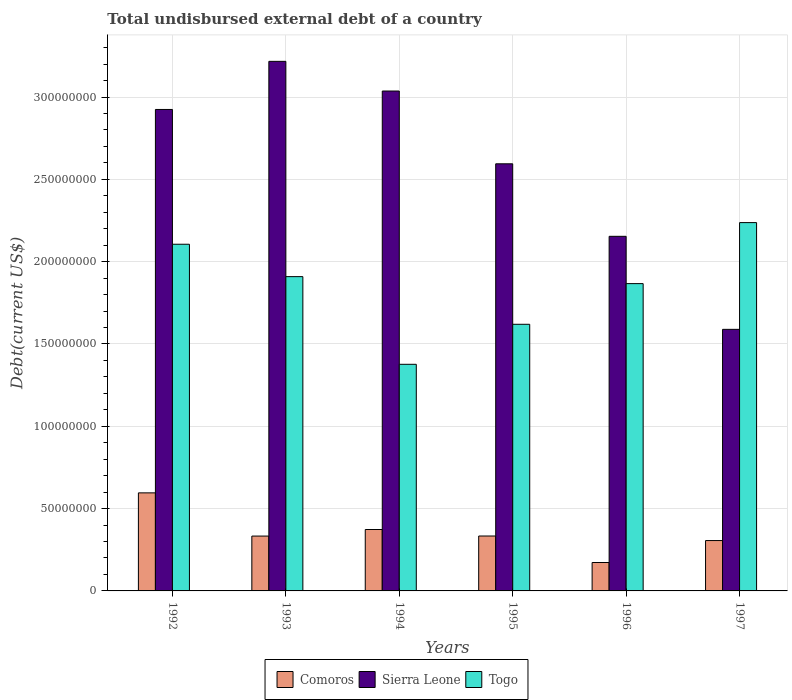How many different coloured bars are there?
Your response must be concise. 3. How many groups of bars are there?
Make the answer very short. 6. Are the number of bars per tick equal to the number of legend labels?
Provide a short and direct response. Yes. Are the number of bars on each tick of the X-axis equal?
Offer a very short reply. Yes. What is the label of the 5th group of bars from the left?
Your response must be concise. 1996. What is the total undisbursed external debt in Sierra Leone in 1993?
Ensure brevity in your answer.  3.22e+08. Across all years, what is the maximum total undisbursed external debt in Comoros?
Your answer should be very brief. 5.96e+07. Across all years, what is the minimum total undisbursed external debt in Comoros?
Offer a very short reply. 1.73e+07. What is the total total undisbursed external debt in Togo in the graph?
Give a very brief answer. 1.11e+09. What is the difference between the total undisbursed external debt in Comoros in 1994 and that in 1996?
Provide a succinct answer. 2.00e+07. What is the difference between the total undisbursed external debt in Sierra Leone in 1994 and the total undisbursed external debt in Comoros in 1995?
Offer a terse response. 2.70e+08. What is the average total undisbursed external debt in Comoros per year?
Keep it short and to the point. 3.52e+07. In the year 1997, what is the difference between the total undisbursed external debt in Sierra Leone and total undisbursed external debt in Comoros?
Offer a terse response. 1.28e+08. What is the ratio of the total undisbursed external debt in Comoros in 1993 to that in 1995?
Provide a short and direct response. 1. What is the difference between the highest and the second highest total undisbursed external debt in Sierra Leone?
Your response must be concise. 1.80e+07. What is the difference between the highest and the lowest total undisbursed external debt in Sierra Leone?
Provide a succinct answer. 1.63e+08. In how many years, is the total undisbursed external debt in Togo greater than the average total undisbursed external debt in Togo taken over all years?
Offer a very short reply. 4. What does the 3rd bar from the left in 1994 represents?
Keep it short and to the point. Togo. What does the 3rd bar from the right in 1997 represents?
Give a very brief answer. Comoros. What is the difference between two consecutive major ticks on the Y-axis?
Ensure brevity in your answer.  5.00e+07. Are the values on the major ticks of Y-axis written in scientific E-notation?
Offer a terse response. No. How are the legend labels stacked?
Provide a short and direct response. Horizontal. What is the title of the graph?
Keep it short and to the point. Total undisbursed external debt of a country. Does "Chad" appear as one of the legend labels in the graph?
Your answer should be compact. No. What is the label or title of the Y-axis?
Provide a short and direct response. Debt(current US$). What is the Debt(current US$) of Comoros in 1992?
Make the answer very short. 5.96e+07. What is the Debt(current US$) in Sierra Leone in 1992?
Your answer should be very brief. 2.92e+08. What is the Debt(current US$) of Togo in 1992?
Your answer should be very brief. 2.11e+08. What is the Debt(current US$) in Comoros in 1993?
Keep it short and to the point. 3.33e+07. What is the Debt(current US$) of Sierra Leone in 1993?
Your answer should be compact. 3.22e+08. What is the Debt(current US$) of Togo in 1993?
Provide a succinct answer. 1.91e+08. What is the Debt(current US$) in Comoros in 1994?
Keep it short and to the point. 3.73e+07. What is the Debt(current US$) in Sierra Leone in 1994?
Offer a very short reply. 3.04e+08. What is the Debt(current US$) in Togo in 1994?
Provide a short and direct response. 1.38e+08. What is the Debt(current US$) of Comoros in 1995?
Give a very brief answer. 3.34e+07. What is the Debt(current US$) of Sierra Leone in 1995?
Provide a succinct answer. 2.59e+08. What is the Debt(current US$) of Togo in 1995?
Keep it short and to the point. 1.62e+08. What is the Debt(current US$) of Comoros in 1996?
Provide a succinct answer. 1.73e+07. What is the Debt(current US$) of Sierra Leone in 1996?
Keep it short and to the point. 2.15e+08. What is the Debt(current US$) of Togo in 1996?
Your answer should be compact. 1.87e+08. What is the Debt(current US$) of Comoros in 1997?
Your answer should be very brief. 3.06e+07. What is the Debt(current US$) of Sierra Leone in 1997?
Offer a very short reply. 1.59e+08. What is the Debt(current US$) of Togo in 1997?
Your response must be concise. 2.24e+08. Across all years, what is the maximum Debt(current US$) in Comoros?
Give a very brief answer. 5.96e+07. Across all years, what is the maximum Debt(current US$) in Sierra Leone?
Ensure brevity in your answer.  3.22e+08. Across all years, what is the maximum Debt(current US$) of Togo?
Keep it short and to the point. 2.24e+08. Across all years, what is the minimum Debt(current US$) of Comoros?
Offer a very short reply. 1.73e+07. Across all years, what is the minimum Debt(current US$) of Sierra Leone?
Provide a short and direct response. 1.59e+08. Across all years, what is the minimum Debt(current US$) in Togo?
Give a very brief answer. 1.38e+08. What is the total Debt(current US$) in Comoros in the graph?
Keep it short and to the point. 2.11e+08. What is the total Debt(current US$) in Sierra Leone in the graph?
Your answer should be very brief. 1.55e+09. What is the total Debt(current US$) in Togo in the graph?
Provide a short and direct response. 1.11e+09. What is the difference between the Debt(current US$) of Comoros in 1992 and that in 1993?
Give a very brief answer. 2.62e+07. What is the difference between the Debt(current US$) of Sierra Leone in 1992 and that in 1993?
Keep it short and to the point. -2.92e+07. What is the difference between the Debt(current US$) in Togo in 1992 and that in 1993?
Offer a very short reply. 1.97e+07. What is the difference between the Debt(current US$) of Comoros in 1992 and that in 1994?
Give a very brief answer. 2.23e+07. What is the difference between the Debt(current US$) in Sierra Leone in 1992 and that in 1994?
Your answer should be compact. -1.12e+07. What is the difference between the Debt(current US$) in Togo in 1992 and that in 1994?
Give a very brief answer. 7.29e+07. What is the difference between the Debt(current US$) of Comoros in 1992 and that in 1995?
Offer a very short reply. 2.62e+07. What is the difference between the Debt(current US$) in Sierra Leone in 1992 and that in 1995?
Offer a very short reply. 3.30e+07. What is the difference between the Debt(current US$) in Togo in 1992 and that in 1995?
Your answer should be very brief. 4.86e+07. What is the difference between the Debt(current US$) of Comoros in 1992 and that in 1996?
Make the answer very short. 4.23e+07. What is the difference between the Debt(current US$) of Sierra Leone in 1992 and that in 1996?
Your response must be concise. 7.71e+07. What is the difference between the Debt(current US$) of Togo in 1992 and that in 1996?
Give a very brief answer. 2.39e+07. What is the difference between the Debt(current US$) of Comoros in 1992 and that in 1997?
Make the answer very short. 2.90e+07. What is the difference between the Debt(current US$) in Sierra Leone in 1992 and that in 1997?
Your response must be concise. 1.34e+08. What is the difference between the Debt(current US$) in Togo in 1992 and that in 1997?
Offer a terse response. -1.31e+07. What is the difference between the Debt(current US$) of Comoros in 1993 and that in 1994?
Offer a very short reply. -3.98e+06. What is the difference between the Debt(current US$) in Sierra Leone in 1993 and that in 1994?
Provide a short and direct response. 1.80e+07. What is the difference between the Debt(current US$) of Togo in 1993 and that in 1994?
Provide a short and direct response. 5.33e+07. What is the difference between the Debt(current US$) of Comoros in 1993 and that in 1995?
Your answer should be very brief. -3.60e+04. What is the difference between the Debt(current US$) of Sierra Leone in 1993 and that in 1995?
Your response must be concise. 6.22e+07. What is the difference between the Debt(current US$) in Togo in 1993 and that in 1995?
Provide a short and direct response. 2.90e+07. What is the difference between the Debt(current US$) in Comoros in 1993 and that in 1996?
Keep it short and to the point. 1.61e+07. What is the difference between the Debt(current US$) of Sierra Leone in 1993 and that in 1996?
Your answer should be very brief. 1.06e+08. What is the difference between the Debt(current US$) in Togo in 1993 and that in 1996?
Ensure brevity in your answer.  4.24e+06. What is the difference between the Debt(current US$) in Comoros in 1993 and that in 1997?
Ensure brevity in your answer.  2.73e+06. What is the difference between the Debt(current US$) of Sierra Leone in 1993 and that in 1997?
Offer a very short reply. 1.63e+08. What is the difference between the Debt(current US$) of Togo in 1993 and that in 1997?
Ensure brevity in your answer.  -3.28e+07. What is the difference between the Debt(current US$) in Comoros in 1994 and that in 1995?
Offer a very short reply. 3.94e+06. What is the difference between the Debt(current US$) of Sierra Leone in 1994 and that in 1995?
Give a very brief answer. 4.42e+07. What is the difference between the Debt(current US$) of Togo in 1994 and that in 1995?
Make the answer very short. -2.43e+07. What is the difference between the Debt(current US$) of Comoros in 1994 and that in 1996?
Your answer should be compact. 2.00e+07. What is the difference between the Debt(current US$) in Sierra Leone in 1994 and that in 1996?
Your response must be concise. 8.83e+07. What is the difference between the Debt(current US$) in Togo in 1994 and that in 1996?
Your answer should be very brief. -4.90e+07. What is the difference between the Debt(current US$) of Comoros in 1994 and that in 1997?
Provide a succinct answer. 6.71e+06. What is the difference between the Debt(current US$) in Sierra Leone in 1994 and that in 1997?
Ensure brevity in your answer.  1.45e+08. What is the difference between the Debt(current US$) in Togo in 1994 and that in 1997?
Make the answer very short. -8.61e+07. What is the difference between the Debt(current US$) of Comoros in 1995 and that in 1996?
Keep it short and to the point. 1.61e+07. What is the difference between the Debt(current US$) in Sierra Leone in 1995 and that in 1996?
Make the answer very short. 4.40e+07. What is the difference between the Debt(current US$) of Togo in 1995 and that in 1996?
Your answer should be compact. -2.47e+07. What is the difference between the Debt(current US$) in Comoros in 1995 and that in 1997?
Your answer should be compact. 2.76e+06. What is the difference between the Debt(current US$) in Sierra Leone in 1995 and that in 1997?
Keep it short and to the point. 1.01e+08. What is the difference between the Debt(current US$) of Togo in 1995 and that in 1997?
Your answer should be compact. -6.18e+07. What is the difference between the Debt(current US$) in Comoros in 1996 and that in 1997?
Offer a very short reply. -1.33e+07. What is the difference between the Debt(current US$) in Sierra Leone in 1996 and that in 1997?
Make the answer very short. 5.65e+07. What is the difference between the Debt(current US$) in Togo in 1996 and that in 1997?
Your answer should be very brief. -3.71e+07. What is the difference between the Debt(current US$) of Comoros in 1992 and the Debt(current US$) of Sierra Leone in 1993?
Provide a succinct answer. -2.62e+08. What is the difference between the Debt(current US$) in Comoros in 1992 and the Debt(current US$) in Togo in 1993?
Your answer should be very brief. -1.31e+08. What is the difference between the Debt(current US$) in Sierra Leone in 1992 and the Debt(current US$) in Togo in 1993?
Provide a succinct answer. 1.02e+08. What is the difference between the Debt(current US$) in Comoros in 1992 and the Debt(current US$) in Sierra Leone in 1994?
Provide a succinct answer. -2.44e+08. What is the difference between the Debt(current US$) in Comoros in 1992 and the Debt(current US$) in Togo in 1994?
Provide a short and direct response. -7.81e+07. What is the difference between the Debt(current US$) in Sierra Leone in 1992 and the Debt(current US$) in Togo in 1994?
Keep it short and to the point. 1.55e+08. What is the difference between the Debt(current US$) of Comoros in 1992 and the Debt(current US$) of Sierra Leone in 1995?
Ensure brevity in your answer.  -2.00e+08. What is the difference between the Debt(current US$) of Comoros in 1992 and the Debt(current US$) of Togo in 1995?
Provide a short and direct response. -1.02e+08. What is the difference between the Debt(current US$) of Sierra Leone in 1992 and the Debt(current US$) of Togo in 1995?
Make the answer very short. 1.30e+08. What is the difference between the Debt(current US$) of Comoros in 1992 and the Debt(current US$) of Sierra Leone in 1996?
Offer a terse response. -1.56e+08. What is the difference between the Debt(current US$) of Comoros in 1992 and the Debt(current US$) of Togo in 1996?
Your answer should be compact. -1.27e+08. What is the difference between the Debt(current US$) of Sierra Leone in 1992 and the Debt(current US$) of Togo in 1996?
Give a very brief answer. 1.06e+08. What is the difference between the Debt(current US$) of Comoros in 1992 and the Debt(current US$) of Sierra Leone in 1997?
Offer a terse response. -9.93e+07. What is the difference between the Debt(current US$) in Comoros in 1992 and the Debt(current US$) in Togo in 1997?
Your answer should be very brief. -1.64e+08. What is the difference between the Debt(current US$) in Sierra Leone in 1992 and the Debt(current US$) in Togo in 1997?
Keep it short and to the point. 6.87e+07. What is the difference between the Debt(current US$) of Comoros in 1993 and the Debt(current US$) of Sierra Leone in 1994?
Give a very brief answer. -2.70e+08. What is the difference between the Debt(current US$) in Comoros in 1993 and the Debt(current US$) in Togo in 1994?
Ensure brevity in your answer.  -1.04e+08. What is the difference between the Debt(current US$) of Sierra Leone in 1993 and the Debt(current US$) of Togo in 1994?
Keep it short and to the point. 1.84e+08. What is the difference between the Debt(current US$) of Comoros in 1993 and the Debt(current US$) of Sierra Leone in 1995?
Your response must be concise. -2.26e+08. What is the difference between the Debt(current US$) in Comoros in 1993 and the Debt(current US$) in Togo in 1995?
Give a very brief answer. -1.29e+08. What is the difference between the Debt(current US$) in Sierra Leone in 1993 and the Debt(current US$) in Togo in 1995?
Keep it short and to the point. 1.60e+08. What is the difference between the Debt(current US$) of Comoros in 1993 and the Debt(current US$) of Sierra Leone in 1996?
Keep it short and to the point. -1.82e+08. What is the difference between the Debt(current US$) of Comoros in 1993 and the Debt(current US$) of Togo in 1996?
Offer a terse response. -1.53e+08. What is the difference between the Debt(current US$) in Sierra Leone in 1993 and the Debt(current US$) in Togo in 1996?
Offer a terse response. 1.35e+08. What is the difference between the Debt(current US$) in Comoros in 1993 and the Debt(current US$) in Sierra Leone in 1997?
Give a very brief answer. -1.26e+08. What is the difference between the Debt(current US$) in Comoros in 1993 and the Debt(current US$) in Togo in 1997?
Provide a short and direct response. -1.90e+08. What is the difference between the Debt(current US$) in Sierra Leone in 1993 and the Debt(current US$) in Togo in 1997?
Make the answer very short. 9.80e+07. What is the difference between the Debt(current US$) of Comoros in 1994 and the Debt(current US$) of Sierra Leone in 1995?
Provide a short and direct response. -2.22e+08. What is the difference between the Debt(current US$) of Comoros in 1994 and the Debt(current US$) of Togo in 1995?
Your response must be concise. -1.25e+08. What is the difference between the Debt(current US$) of Sierra Leone in 1994 and the Debt(current US$) of Togo in 1995?
Your answer should be compact. 1.42e+08. What is the difference between the Debt(current US$) in Comoros in 1994 and the Debt(current US$) in Sierra Leone in 1996?
Your answer should be very brief. -1.78e+08. What is the difference between the Debt(current US$) in Comoros in 1994 and the Debt(current US$) in Togo in 1996?
Your answer should be very brief. -1.49e+08. What is the difference between the Debt(current US$) of Sierra Leone in 1994 and the Debt(current US$) of Togo in 1996?
Your response must be concise. 1.17e+08. What is the difference between the Debt(current US$) in Comoros in 1994 and the Debt(current US$) in Sierra Leone in 1997?
Ensure brevity in your answer.  -1.22e+08. What is the difference between the Debt(current US$) of Comoros in 1994 and the Debt(current US$) of Togo in 1997?
Keep it short and to the point. -1.86e+08. What is the difference between the Debt(current US$) of Sierra Leone in 1994 and the Debt(current US$) of Togo in 1997?
Keep it short and to the point. 7.99e+07. What is the difference between the Debt(current US$) in Comoros in 1995 and the Debt(current US$) in Sierra Leone in 1996?
Ensure brevity in your answer.  -1.82e+08. What is the difference between the Debt(current US$) in Comoros in 1995 and the Debt(current US$) in Togo in 1996?
Your answer should be compact. -1.53e+08. What is the difference between the Debt(current US$) in Sierra Leone in 1995 and the Debt(current US$) in Togo in 1996?
Your answer should be very brief. 7.28e+07. What is the difference between the Debt(current US$) in Comoros in 1995 and the Debt(current US$) in Sierra Leone in 1997?
Provide a short and direct response. -1.26e+08. What is the difference between the Debt(current US$) in Comoros in 1995 and the Debt(current US$) in Togo in 1997?
Offer a terse response. -1.90e+08. What is the difference between the Debt(current US$) of Sierra Leone in 1995 and the Debt(current US$) of Togo in 1997?
Provide a succinct answer. 3.57e+07. What is the difference between the Debt(current US$) of Comoros in 1996 and the Debt(current US$) of Sierra Leone in 1997?
Provide a succinct answer. -1.42e+08. What is the difference between the Debt(current US$) of Comoros in 1996 and the Debt(current US$) of Togo in 1997?
Give a very brief answer. -2.06e+08. What is the difference between the Debt(current US$) of Sierra Leone in 1996 and the Debt(current US$) of Togo in 1997?
Ensure brevity in your answer.  -8.33e+06. What is the average Debt(current US$) of Comoros per year?
Your answer should be very brief. 3.52e+07. What is the average Debt(current US$) in Sierra Leone per year?
Provide a short and direct response. 2.59e+08. What is the average Debt(current US$) in Togo per year?
Your answer should be compact. 1.85e+08. In the year 1992, what is the difference between the Debt(current US$) in Comoros and Debt(current US$) in Sierra Leone?
Make the answer very short. -2.33e+08. In the year 1992, what is the difference between the Debt(current US$) of Comoros and Debt(current US$) of Togo?
Offer a very short reply. -1.51e+08. In the year 1992, what is the difference between the Debt(current US$) of Sierra Leone and Debt(current US$) of Togo?
Your response must be concise. 8.19e+07. In the year 1993, what is the difference between the Debt(current US$) in Comoros and Debt(current US$) in Sierra Leone?
Your answer should be very brief. -2.88e+08. In the year 1993, what is the difference between the Debt(current US$) of Comoros and Debt(current US$) of Togo?
Your response must be concise. -1.58e+08. In the year 1993, what is the difference between the Debt(current US$) in Sierra Leone and Debt(current US$) in Togo?
Keep it short and to the point. 1.31e+08. In the year 1994, what is the difference between the Debt(current US$) in Comoros and Debt(current US$) in Sierra Leone?
Your answer should be compact. -2.66e+08. In the year 1994, what is the difference between the Debt(current US$) in Comoros and Debt(current US$) in Togo?
Make the answer very short. -1.00e+08. In the year 1994, what is the difference between the Debt(current US$) in Sierra Leone and Debt(current US$) in Togo?
Offer a very short reply. 1.66e+08. In the year 1995, what is the difference between the Debt(current US$) in Comoros and Debt(current US$) in Sierra Leone?
Your response must be concise. -2.26e+08. In the year 1995, what is the difference between the Debt(current US$) of Comoros and Debt(current US$) of Togo?
Your answer should be compact. -1.29e+08. In the year 1995, what is the difference between the Debt(current US$) in Sierra Leone and Debt(current US$) in Togo?
Your answer should be very brief. 9.75e+07. In the year 1996, what is the difference between the Debt(current US$) of Comoros and Debt(current US$) of Sierra Leone?
Offer a very short reply. -1.98e+08. In the year 1996, what is the difference between the Debt(current US$) of Comoros and Debt(current US$) of Togo?
Your answer should be compact. -1.69e+08. In the year 1996, what is the difference between the Debt(current US$) in Sierra Leone and Debt(current US$) in Togo?
Keep it short and to the point. 2.87e+07. In the year 1997, what is the difference between the Debt(current US$) in Comoros and Debt(current US$) in Sierra Leone?
Provide a succinct answer. -1.28e+08. In the year 1997, what is the difference between the Debt(current US$) of Comoros and Debt(current US$) of Togo?
Your response must be concise. -1.93e+08. In the year 1997, what is the difference between the Debt(current US$) in Sierra Leone and Debt(current US$) in Togo?
Your answer should be compact. -6.48e+07. What is the ratio of the Debt(current US$) of Comoros in 1992 to that in 1993?
Your answer should be very brief. 1.79. What is the ratio of the Debt(current US$) in Sierra Leone in 1992 to that in 1993?
Make the answer very short. 0.91. What is the ratio of the Debt(current US$) of Togo in 1992 to that in 1993?
Offer a terse response. 1.1. What is the ratio of the Debt(current US$) of Comoros in 1992 to that in 1994?
Keep it short and to the point. 1.6. What is the ratio of the Debt(current US$) in Sierra Leone in 1992 to that in 1994?
Provide a short and direct response. 0.96. What is the ratio of the Debt(current US$) of Togo in 1992 to that in 1994?
Make the answer very short. 1.53. What is the ratio of the Debt(current US$) of Comoros in 1992 to that in 1995?
Provide a short and direct response. 1.79. What is the ratio of the Debt(current US$) in Sierra Leone in 1992 to that in 1995?
Provide a succinct answer. 1.13. What is the ratio of the Debt(current US$) in Togo in 1992 to that in 1995?
Offer a very short reply. 1.3. What is the ratio of the Debt(current US$) of Comoros in 1992 to that in 1996?
Your response must be concise. 3.45. What is the ratio of the Debt(current US$) in Sierra Leone in 1992 to that in 1996?
Your response must be concise. 1.36. What is the ratio of the Debt(current US$) in Togo in 1992 to that in 1996?
Provide a short and direct response. 1.13. What is the ratio of the Debt(current US$) in Comoros in 1992 to that in 1997?
Keep it short and to the point. 1.95. What is the ratio of the Debt(current US$) of Sierra Leone in 1992 to that in 1997?
Keep it short and to the point. 1.84. What is the ratio of the Debt(current US$) of Togo in 1992 to that in 1997?
Provide a succinct answer. 0.94. What is the ratio of the Debt(current US$) of Comoros in 1993 to that in 1994?
Offer a terse response. 0.89. What is the ratio of the Debt(current US$) in Sierra Leone in 1993 to that in 1994?
Your answer should be compact. 1.06. What is the ratio of the Debt(current US$) of Togo in 1993 to that in 1994?
Your response must be concise. 1.39. What is the ratio of the Debt(current US$) of Comoros in 1993 to that in 1995?
Provide a short and direct response. 1. What is the ratio of the Debt(current US$) in Sierra Leone in 1993 to that in 1995?
Provide a succinct answer. 1.24. What is the ratio of the Debt(current US$) in Togo in 1993 to that in 1995?
Provide a short and direct response. 1.18. What is the ratio of the Debt(current US$) in Comoros in 1993 to that in 1996?
Keep it short and to the point. 1.93. What is the ratio of the Debt(current US$) in Sierra Leone in 1993 to that in 1996?
Your answer should be very brief. 1.49. What is the ratio of the Debt(current US$) in Togo in 1993 to that in 1996?
Provide a succinct answer. 1.02. What is the ratio of the Debt(current US$) of Comoros in 1993 to that in 1997?
Provide a succinct answer. 1.09. What is the ratio of the Debt(current US$) of Sierra Leone in 1993 to that in 1997?
Make the answer very short. 2.02. What is the ratio of the Debt(current US$) in Togo in 1993 to that in 1997?
Ensure brevity in your answer.  0.85. What is the ratio of the Debt(current US$) of Comoros in 1994 to that in 1995?
Provide a succinct answer. 1.12. What is the ratio of the Debt(current US$) of Sierra Leone in 1994 to that in 1995?
Offer a terse response. 1.17. What is the ratio of the Debt(current US$) of Togo in 1994 to that in 1995?
Make the answer very short. 0.85. What is the ratio of the Debt(current US$) in Comoros in 1994 to that in 1996?
Provide a short and direct response. 2.16. What is the ratio of the Debt(current US$) of Sierra Leone in 1994 to that in 1996?
Provide a short and direct response. 1.41. What is the ratio of the Debt(current US$) in Togo in 1994 to that in 1996?
Ensure brevity in your answer.  0.74. What is the ratio of the Debt(current US$) in Comoros in 1994 to that in 1997?
Offer a terse response. 1.22. What is the ratio of the Debt(current US$) in Sierra Leone in 1994 to that in 1997?
Provide a short and direct response. 1.91. What is the ratio of the Debt(current US$) of Togo in 1994 to that in 1997?
Offer a terse response. 0.62. What is the ratio of the Debt(current US$) in Comoros in 1995 to that in 1996?
Offer a terse response. 1.93. What is the ratio of the Debt(current US$) in Sierra Leone in 1995 to that in 1996?
Your response must be concise. 1.2. What is the ratio of the Debt(current US$) in Togo in 1995 to that in 1996?
Offer a terse response. 0.87. What is the ratio of the Debt(current US$) in Comoros in 1995 to that in 1997?
Your response must be concise. 1.09. What is the ratio of the Debt(current US$) of Sierra Leone in 1995 to that in 1997?
Your answer should be very brief. 1.63. What is the ratio of the Debt(current US$) of Togo in 1995 to that in 1997?
Ensure brevity in your answer.  0.72. What is the ratio of the Debt(current US$) in Comoros in 1996 to that in 1997?
Ensure brevity in your answer.  0.56. What is the ratio of the Debt(current US$) of Sierra Leone in 1996 to that in 1997?
Provide a short and direct response. 1.36. What is the ratio of the Debt(current US$) of Togo in 1996 to that in 1997?
Your response must be concise. 0.83. What is the difference between the highest and the second highest Debt(current US$) in Comoros?
Offer a terse response. 2.23e+07. What is the difference between the highest and the second highest Debt(current US$) of Sierra Leone?
Offer a very short reply. 1.80e+07. What is the difference between the highest and the second highest Debt(current US$) of Togo?
Give a very brief answer. 1.31e+07. What is the difference between the highest and the lowest Debt(current US$) of Comoros?
Ensure brevity in your answer.  4.23e+07. What is the difference between the highest and the lowest Debt(current US$) in Sierra Leone?
Offer a very short reply. 1.63e+08. What is the difference between the highest and the lowest Debt(current US$) of Togo?
Ensure brevity in your answer.  8.61e+07. 